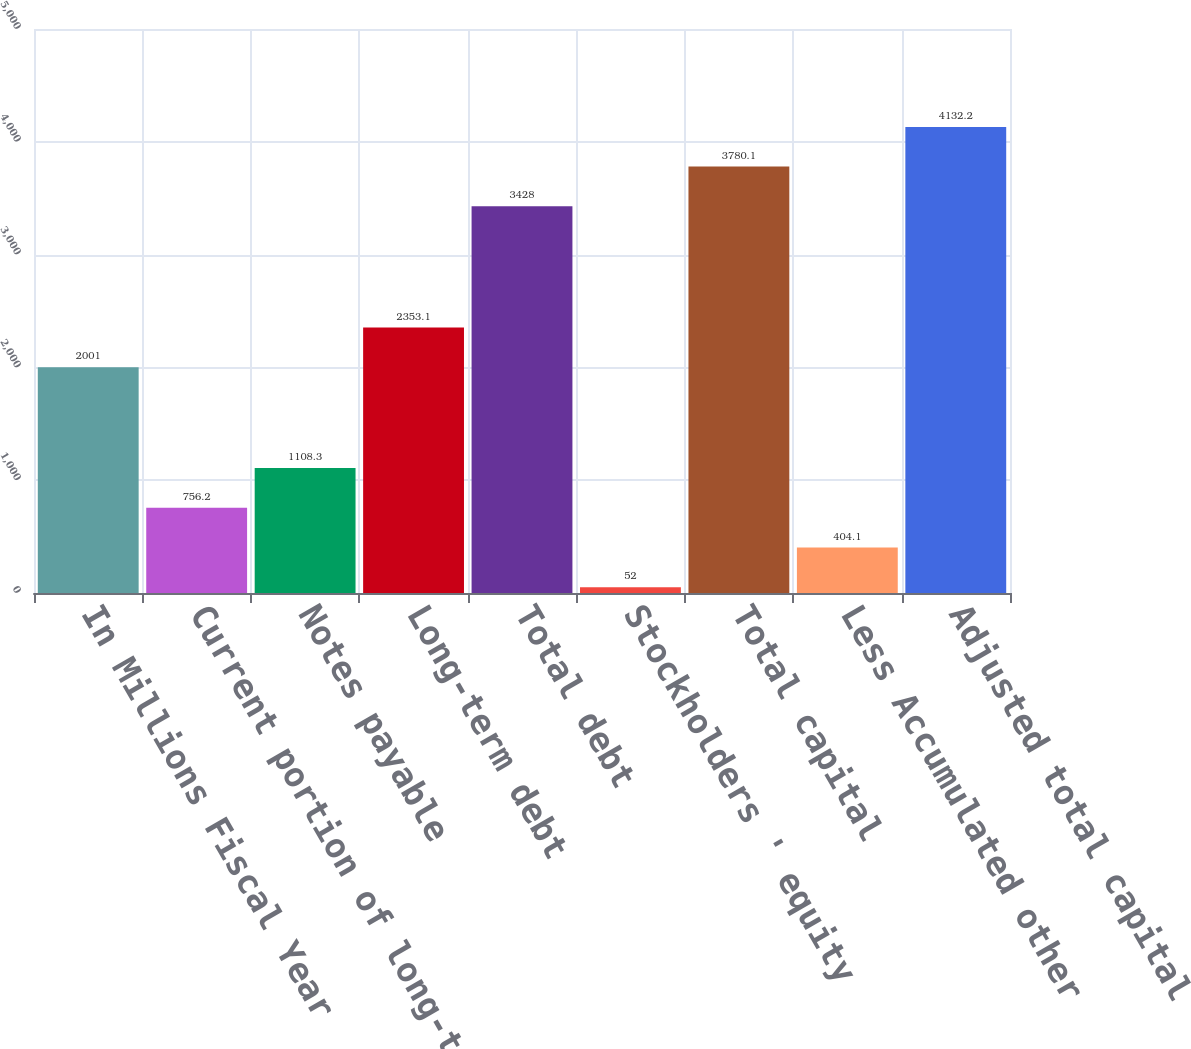Convert chart. <chart><loc_0><loc_0><loc_500><loc_500><bar_chart><fcel>In Millions Fiscal Year<fcel>Current portion of long-term<fcel>Notes payable<fcel>Long-term debt<fcel>Total debt<fcel>Stockholders ' equity<fcel>Total capital<fcel>Less Accumulated other<fcel>Adjusted total capital<nl><fcel>2001<fcel>756.2<fcel>1108.3<fcel>2353.1<fcel>3428<fcel>52<fcel>3780.1<fcel>404.1<fcel>4132.2<nl></chart> 